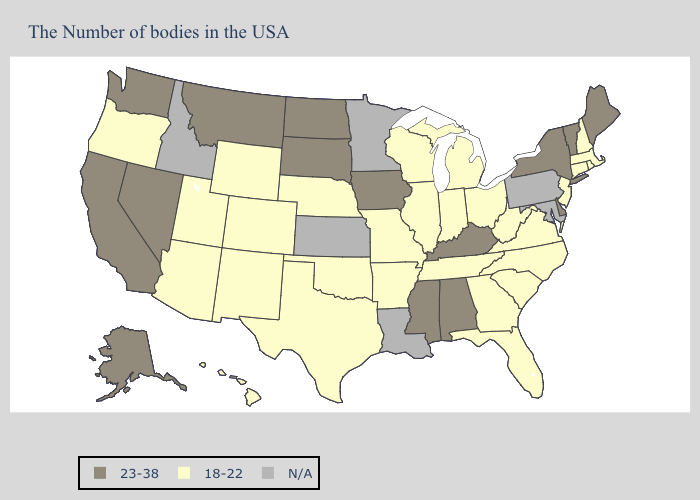Does Alabama have the lowest value in the South?
Quick response, please. No. Name the states that have a value in the range 18-22?
Short answer required. Massachusetts, Rhode Island, New Hampshire, Connecticut, New Jersey, Virginia, North Carolina, South Carolina, West Virginia, Ohio, Florida, Georgia, Michigan, Indiana, Tennessee, Wisconsin, Illinois, Missouri, Arkansas, Nebraska, Oklahoma, Texas, Wyoming, Colorado, New Mexico, Utah, Arizona, Oregon, Hawaii. What is the value of Wisconsin?
Quick response, please. 18-22. Among the states that border Arkansas , does Missouri have the highest value?
Keep it brief. No. What is the value of Alaska?
Write a very short answer. 23-38. What is the lowest value in the USA?
Write a very short answer. 18-22. What is the highest value in the USA?
Concise answer only. 23-38. Which states hav the highest value in the South?
Concise answer only. Delaware, Kentucky, Alabama, Mississippi. What is the value of Wyoming?
Short answer required. 18-22. What is the value of Minnesota?
Short answer required. N/A. What is the value of North Carolina?
Write a very short answer. 18-22. What is the value of Hawaii?
Give a very brief answer. 18-22. Does the first symbol in the legend represent the smallest category?
Be succinct. No. What is the highest value in states that border Florida?
Keep it brief. 23-38. Name the states that have a value in the range 23-38?
Be succinct. Maine, Vermont, New York, Delaware, Kentucky, Alabama, Mississippi, Iowa, South Dakota, North Dakota, Montana, Nevada, California, Washington, Alaska. 